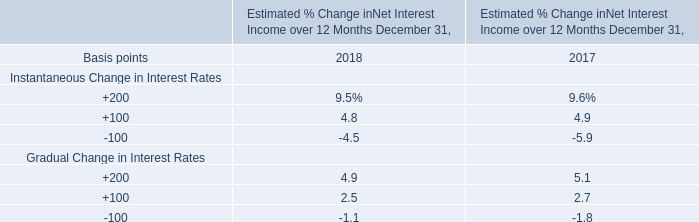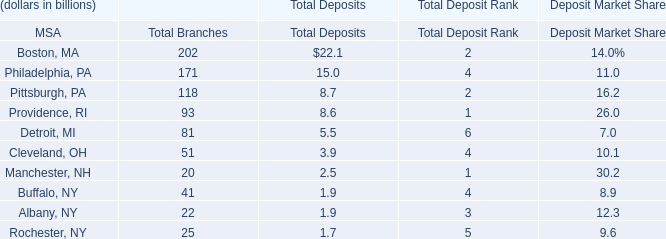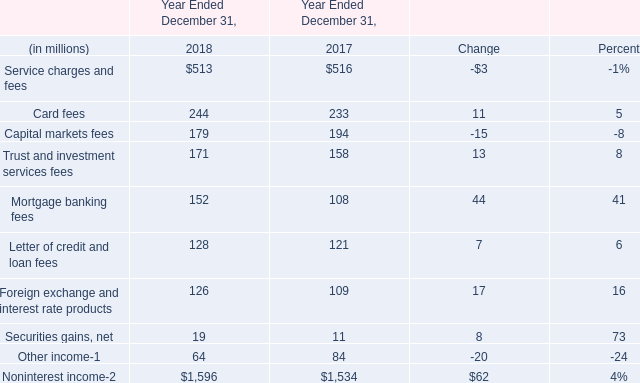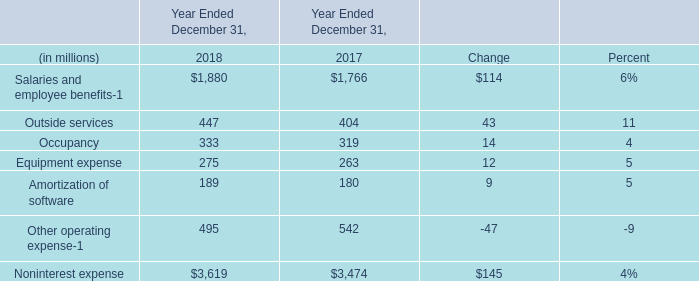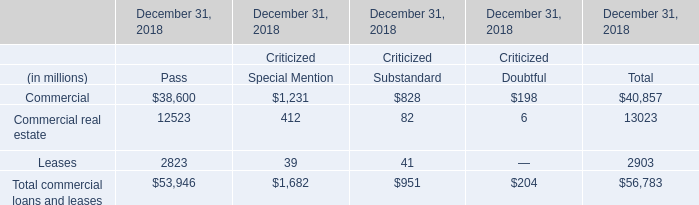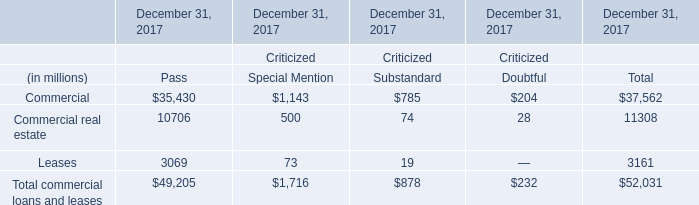What was the total amount of Service charges and fees in the range of 0 and 600 in2018? (in million) 
Answer: 513. 